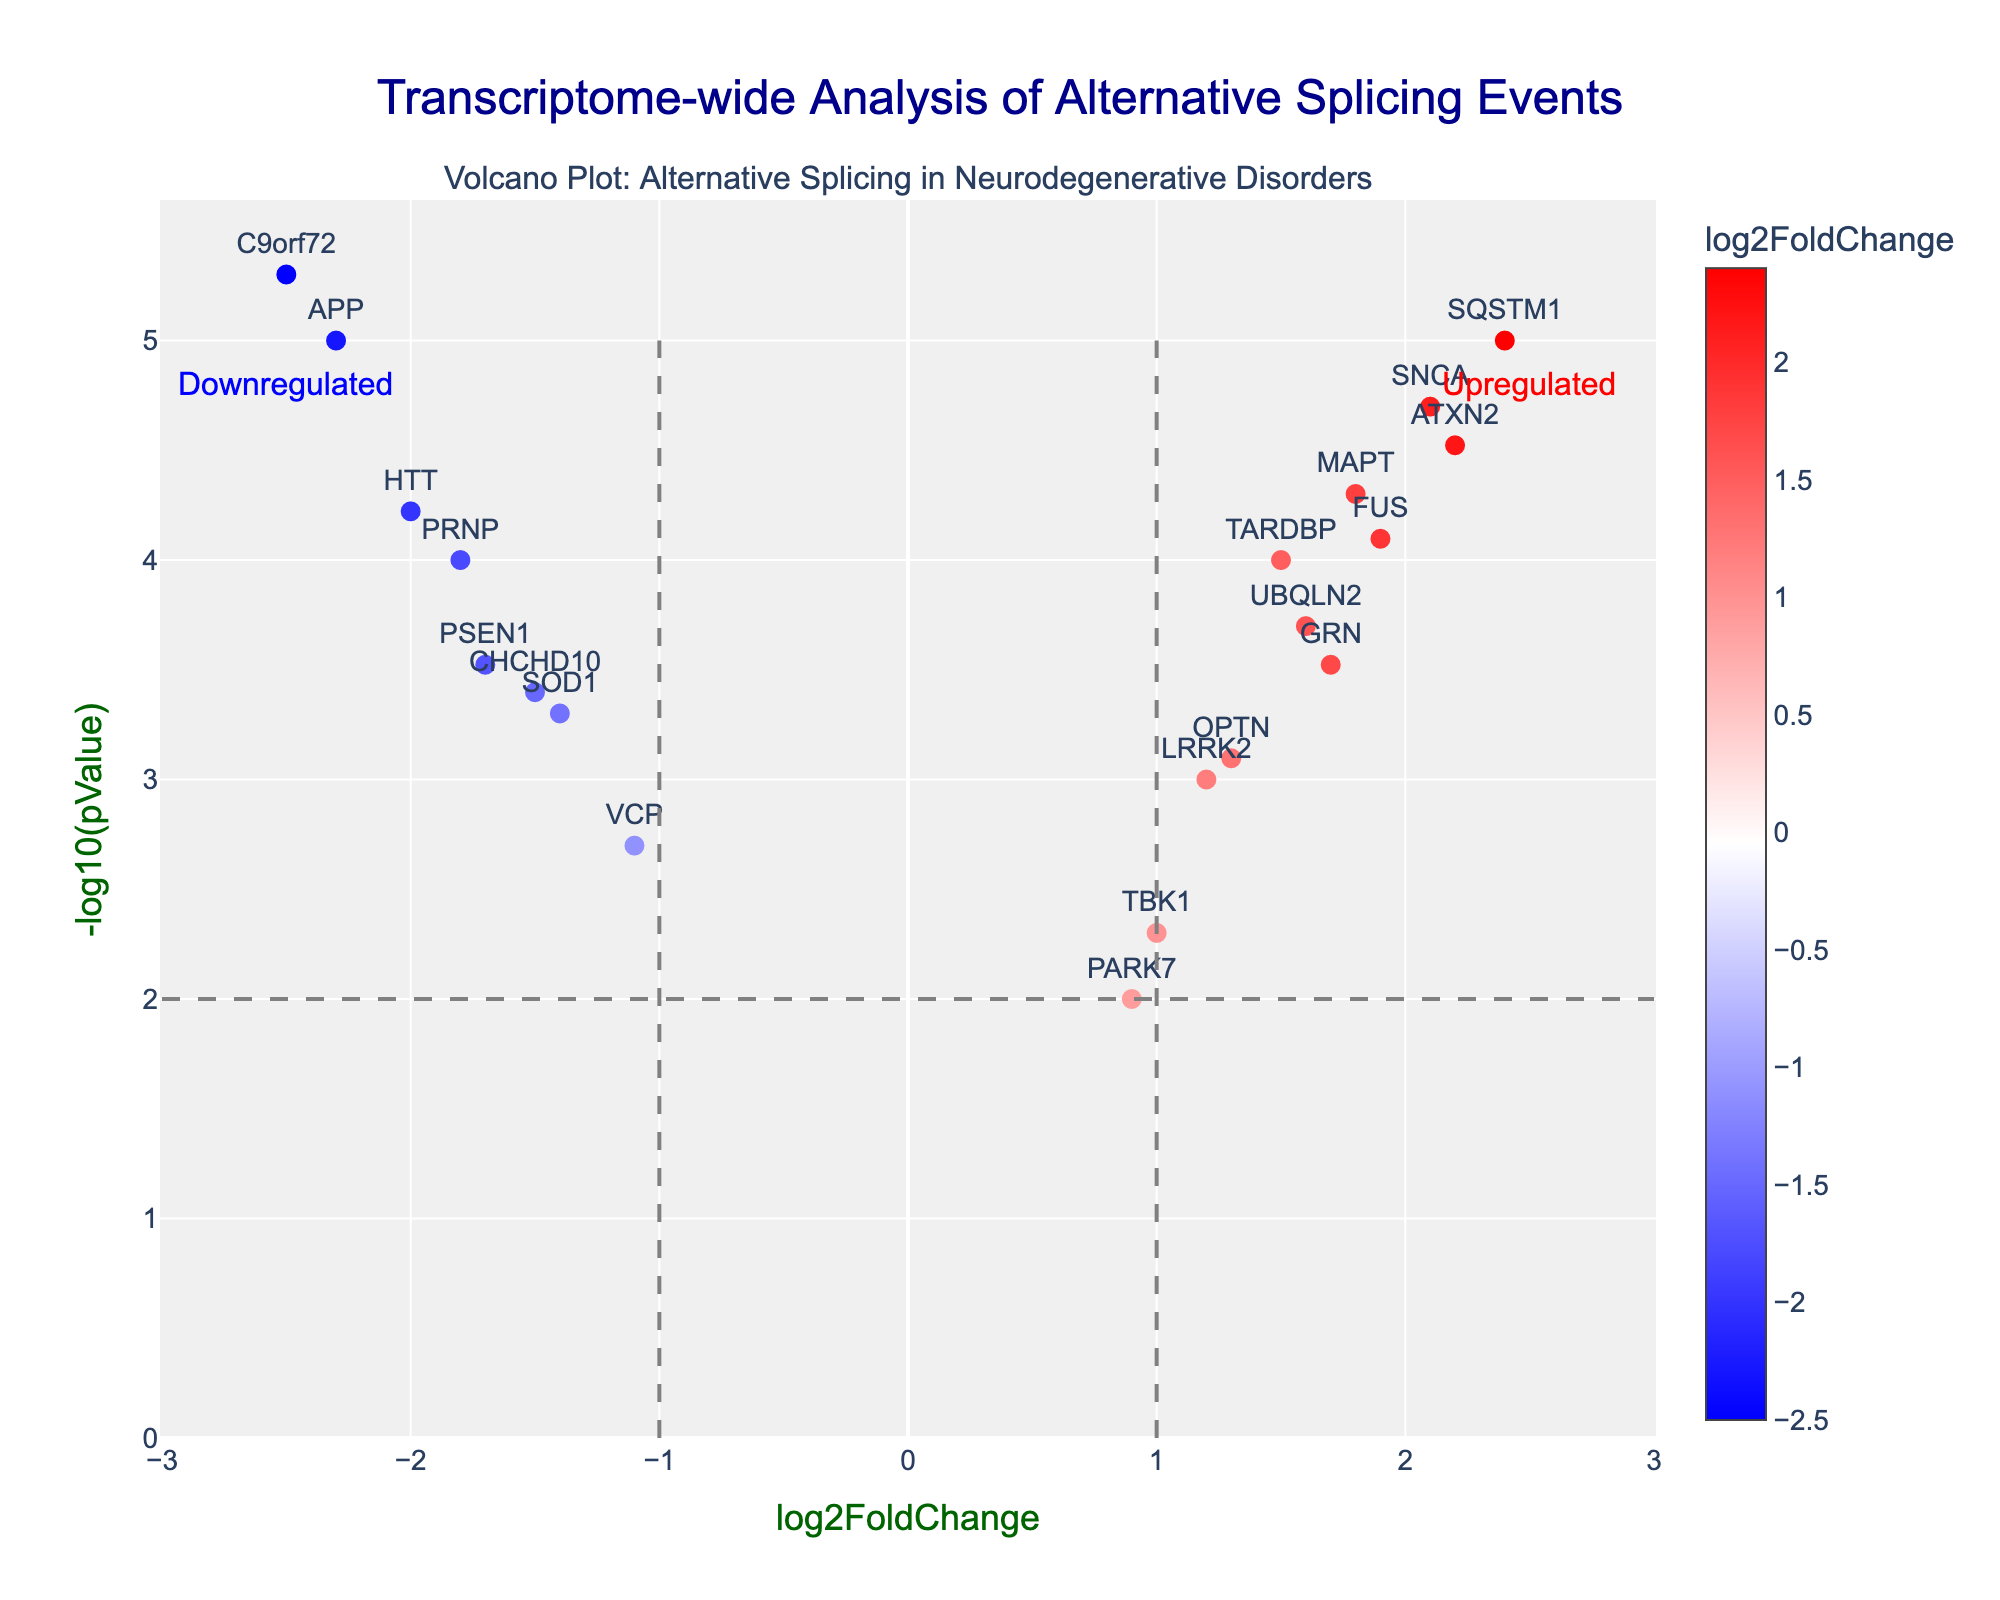What does the x-axis represent in the plot? The x-axis represents the log2FoldChange, which indicates the magnitude of change in exon inclusion or exclusion rates between conditions. Negative values indicate exons with decreased inclusion rates, while positive values indicate exons with increased inclusion rates.
Answer: log2FoldChange What is the title of the volcano plot? The title of the plot is "Transcriptome-wide Analysis of Alternative Splicing Events." This title provides an overview of the analysis performed on splicing events specifically in the context of neurodegenerative disorders.
Answer: Transcriptome-wide Analysis of Alternative Splicing Events Which gene exhibits the highest degree of upregulation? By observing the plot, the gene with the highest log2FoldChange (furthest to the right) indicates the highest degree of upregulation. The gene SQSTM1 is the most upregulated with a log2FoldChange of 2.4.
Answer: SQSTM1 How many genes have a log2FoldChange greater than 1.5? To determine this, count the number of data points (genes) that position to the right of the log2FoldChange value of 1.5 on the x-axis. From the plot, there are 5 genes with a log2FoldChange greater than 1.5: MAPT, FUS, ATXN2, GRN, and SQSTM1.
Answer: 5 Which gene has the highest significance level (lowest p-value)? To identify this gene, look for the data point with the highest value on the y-axis (-log10(pValue)). The highest point corresponds to the gene C9orf72, indicating it has the lowest p-value and highest significance.
Answer: C9orf72 Compare the inclusion rates of APP and LRRK2. Which gene shows a more significant change in inclusion rate? The inclusion rate change is reflected by the log2FoldChange. For APP, the log2FoldChange is -2.3, and for LRRK2, it is 1.2. APP shows a more significant change in inclusion rate as its log2FoldChange is farther from zero.
Answer: APP Across all genes, what is the range of log2FoldChange values? By inspecting the x-axis, the smallest log2FoldChange is for C9orf72 at -2.5, and the largest is for SQSTM1 at 2.4. The range is calculated as 2.4 - (-2.5) = 4.9.
Answer: 4.9 Which genes show significant downregulation and have a log2FoldChange less than -1.2? Significant downregulation genes are found on the left of the plot with log2FoldChange less than -1.2. These genes are APP (-2.3), PSEN1 (-1.7), C9orf72 (-2.5), SOD1 (-1.4), HTT (-2.0), PRNP (-1.8), and CHCHD10 (-1.5).
Answer: APP, PSEN1, C9orf72, SOD1, HTT, PRNP, CHCHD10 What does the color scale represent in the plot? The color scale indicates the log2FoldChange values, where blue represents downregulation, red represents upregulation, and white represents near-zero change. This helps in visually distinguishing the degree of exon inclusion or exclusion rates.
Answer: log2FoldChange 